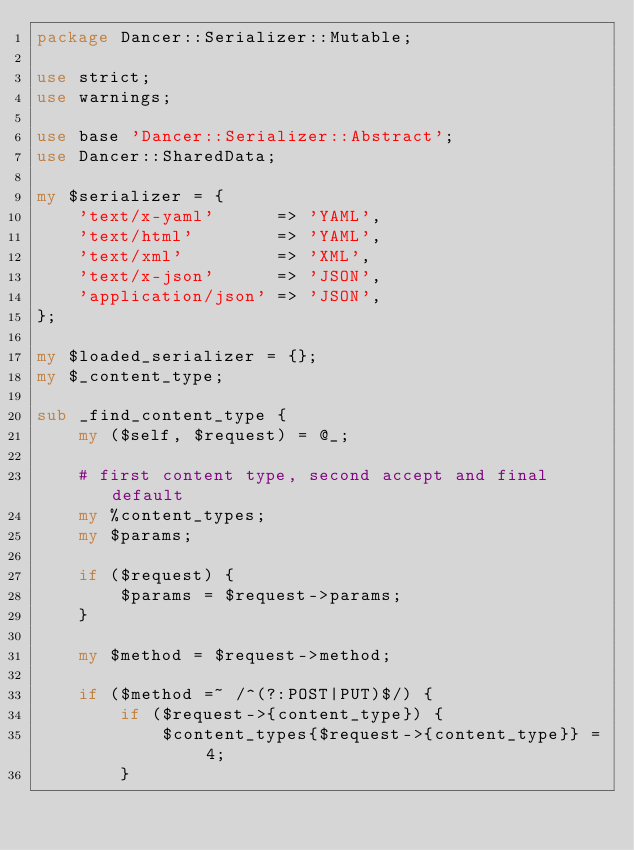<code> <loc_0><loc_0><loc_500><loc_500><_Perl_>package Dancer::Serializer::Mutable;

use strict;
use warnings;

use base 'Dancer::Serializer::Abstract';
use Dancer::SharedData;

my $serializer = {
    'text/x-yaml'      => 'YAML',
    'text/html'        => 'YAML',
    'text/xml'         => 'XML',
    'text/x-json'      => 'JSON',
    'application/json' => 'JSON',
};

my $loaded_serializer = {};
my $_content_type;

sub _find_content_type {
    my ($self, $request) = @_;

    # first content type, second accept and final default
    my %content_types;
    my $params;

    if ($request) {
        $params = $request->params;
    }

    my $method = $request->method;

    if ($method =~ /^(?:POST|PUT)$/) {
        if ($request->{content_type}) {
            $content_types{$request->{content_type}} = 4;
        }
</code> 